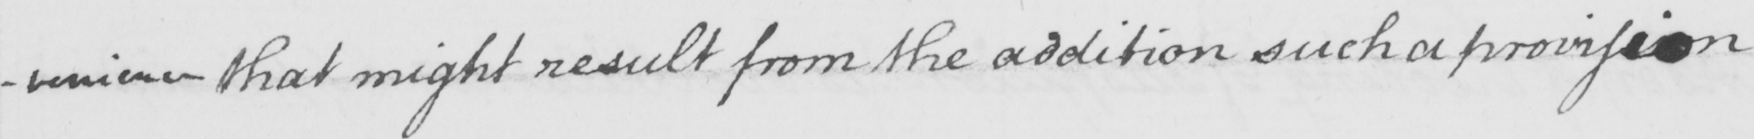Transcribe the text shown in this historical manuscript line. -venience that might result from the addition such a provision 